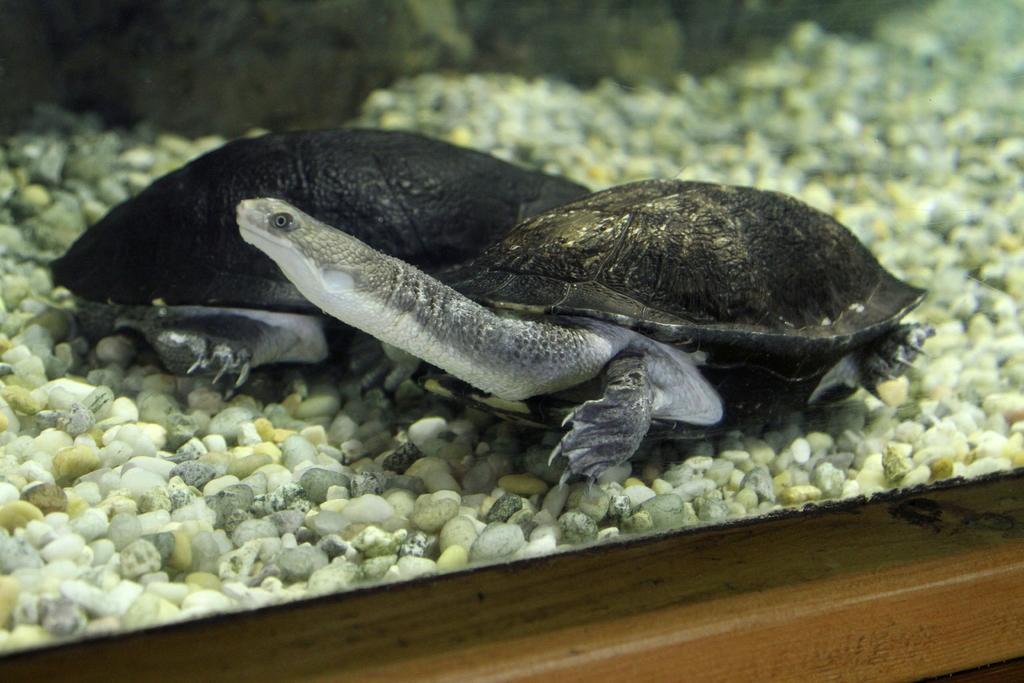Please provide a concise description of this image. In this image there is an aquarium with water, aquarium stones and two turtles in it. The aquarium is placed on the wooden table. 